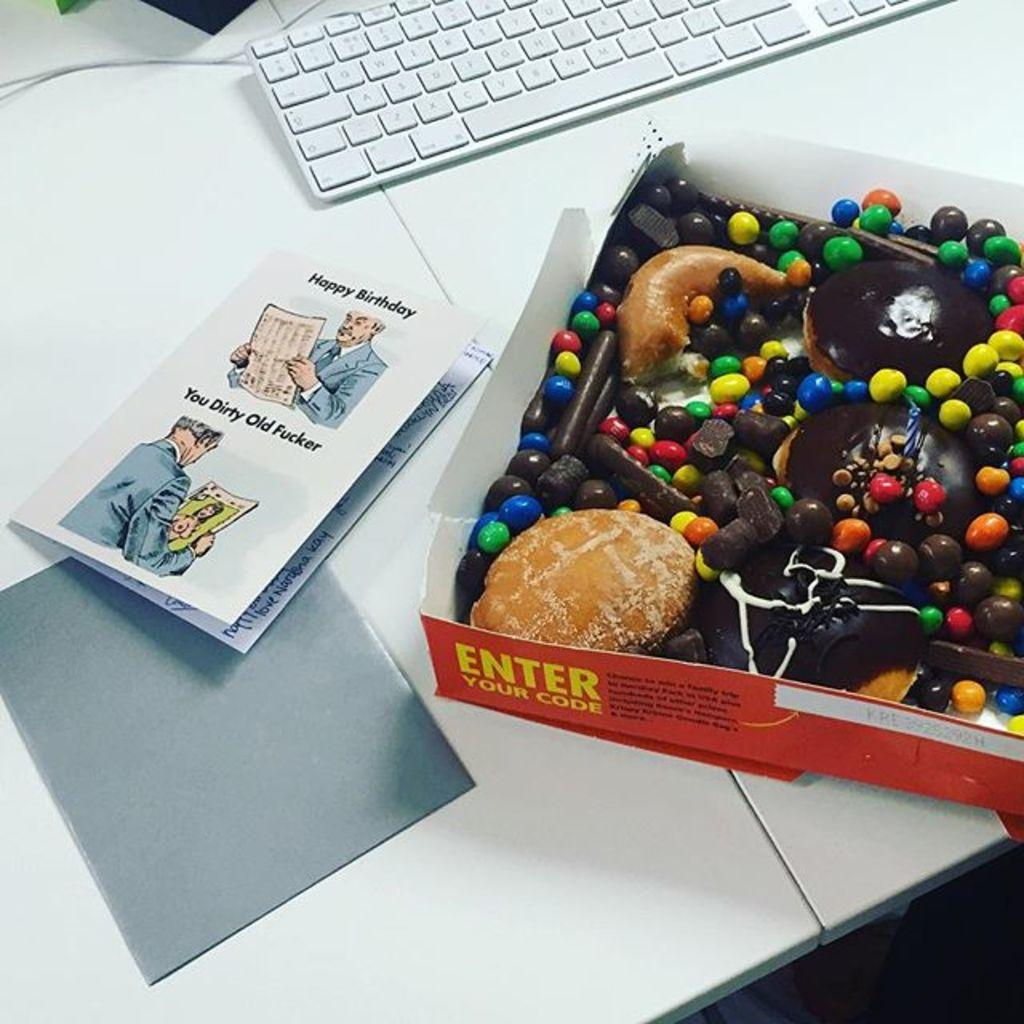<image>
Offer a succinct explanation of the picture presented. A box of doughnuts next to a card reading Happy Birthday. 